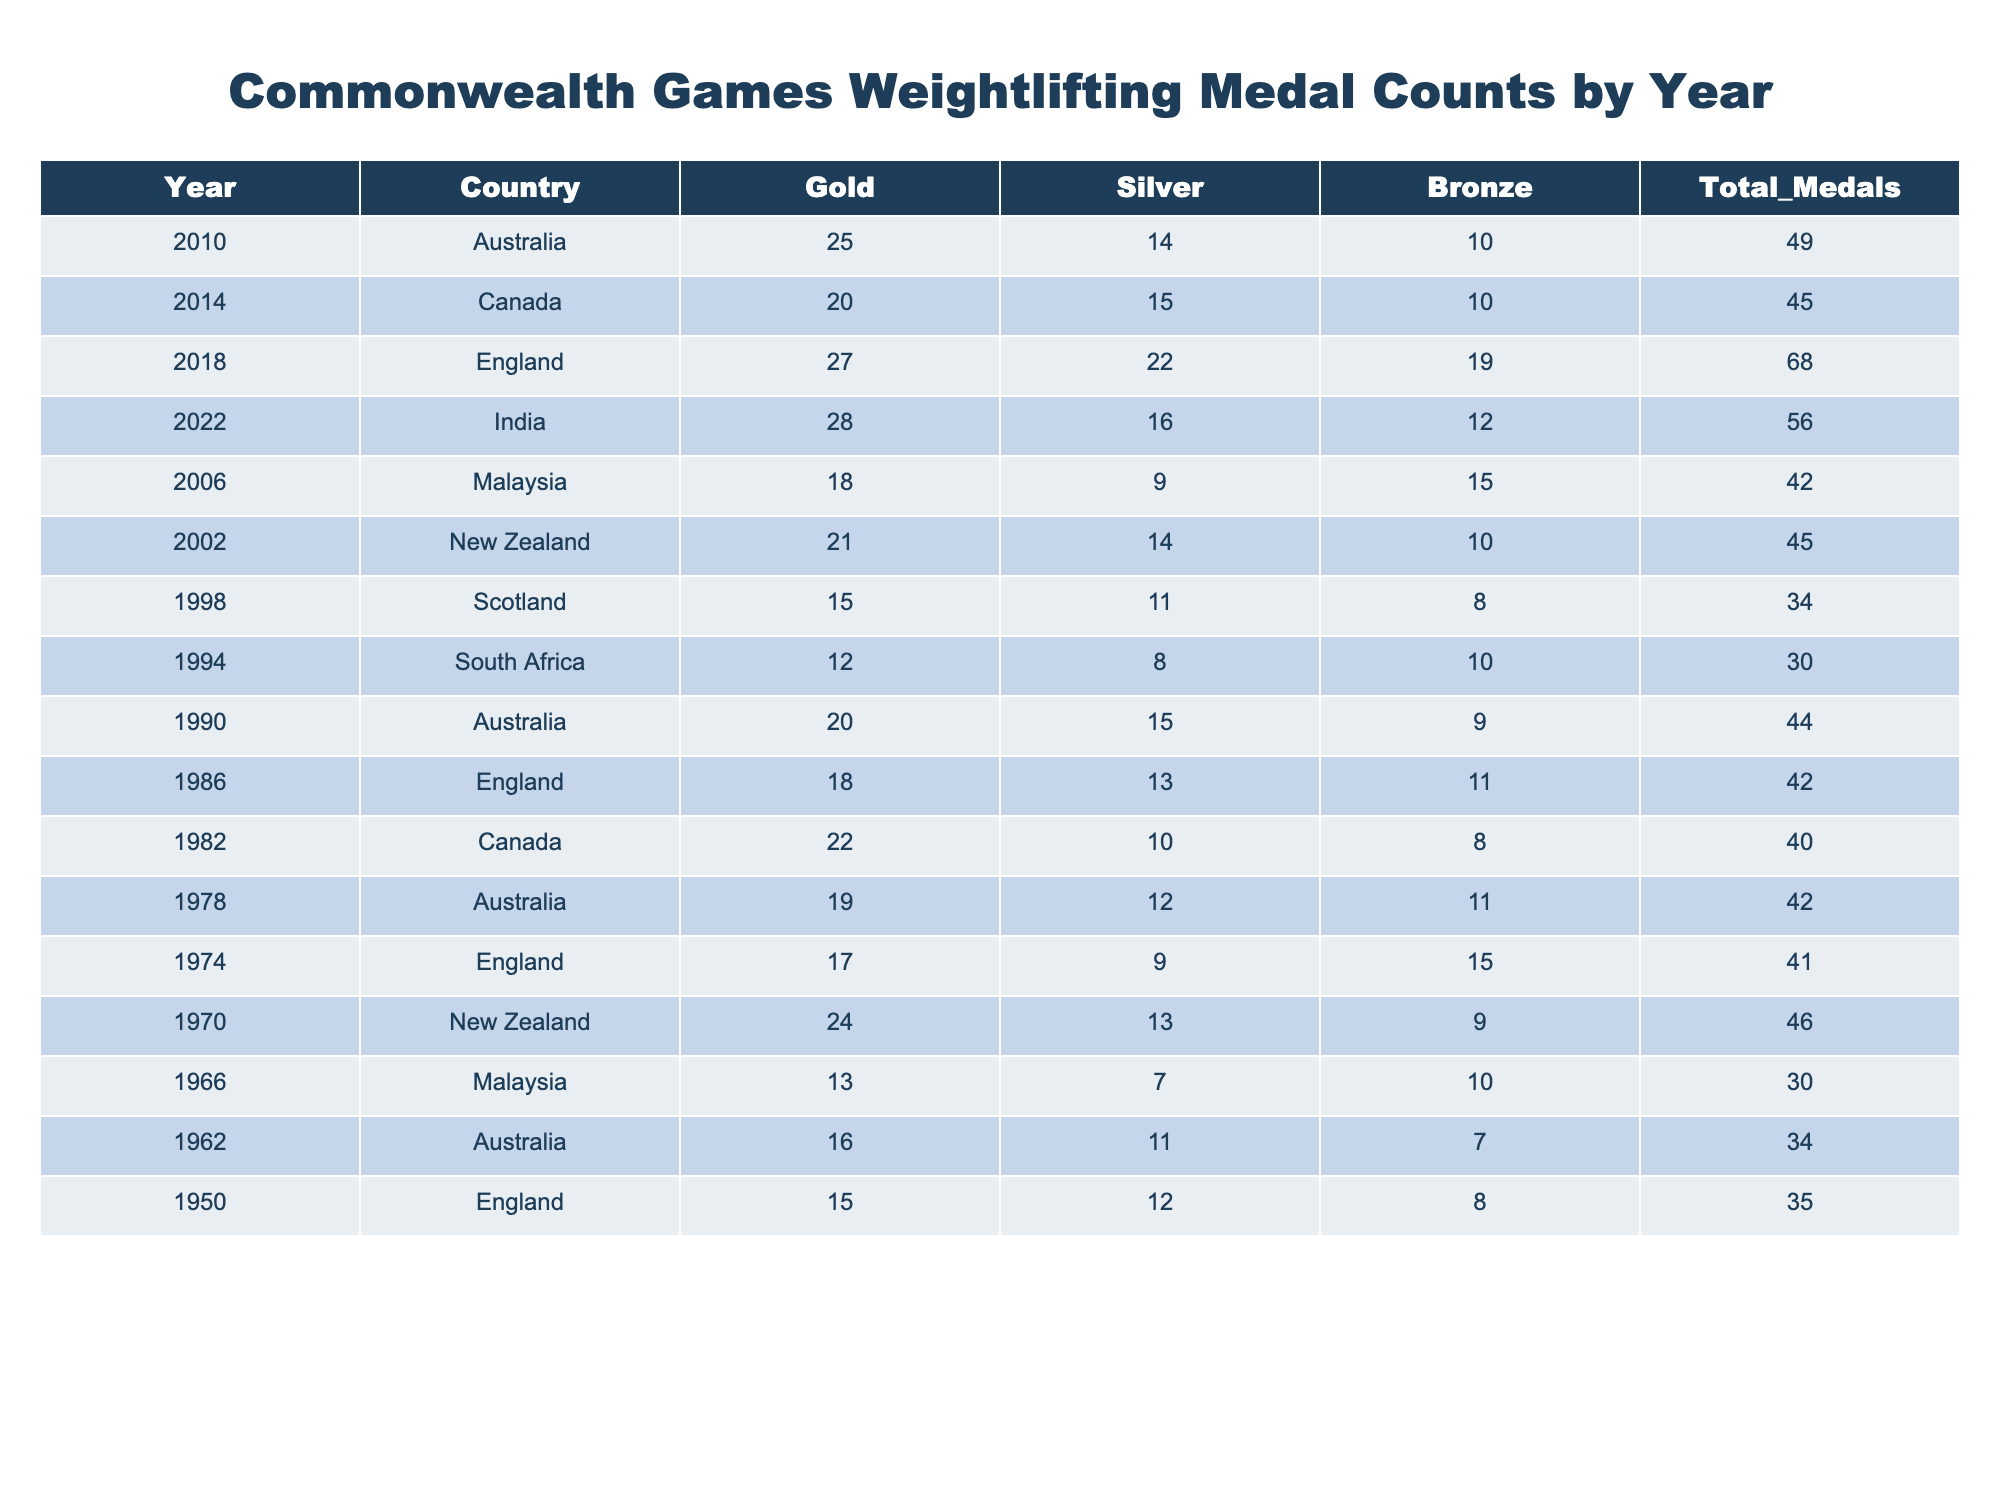What country won the most gold medals in 2018? In 2018, England won the most gold medals, with a total of 27 golds.
Answer: England Which year had the highest total medal count? The year with the highest total medal count is 2018, with a total of 68 medals.
Answer: 2018 Did Australia win more gold medals than New Zealand in 2002? Yes, Australia won 21 gold medals, while New Zealand won 21 as well, making it a tie.
Answer: Yes What is the average number of silver medals won by Malaysia across all years? The number of silver medals won by Malaysia is 9 in 2006 and 7 in 1966, totaling 16. Dividing this by the 2 events gives an average of 8.
Answer: 8 In which year did India win its first recorded medal count? India recorded its first medal count in 2022, with a total of 56 medals.
Answer: 2022 Which country had more bronze medals, Canada or South Africa, in 2014 and 1994 respectively? Canada had 10 bronze medals in 2014 while South Africa had 10 bronze medals in 1994, making it a tie in this case as well.
Answer: Tie How many more total medals did England win in 2018 compared to Australia in 2010? England won 68 total medals in 2018, and Australia won 49 total medals in 2010. The difference between them is 68 - 49 = 19 medals.
Answer: 19 What percentage of all medals in 1974 were silver? In 1974, a total of 41 medals were won, and 9 of them were silver. Thus, the percentage of silver medals is (9/41) * 100, which equals approximately 21.95%.
Answer: 21.95% What is the total number of bronze medals won by New Zealand across all years? New Zealand won 10 bronze medals in 2002 and 9 in 1970. Adding these gives 10 + 9 = 19 bronze medals.
Answer: 19 